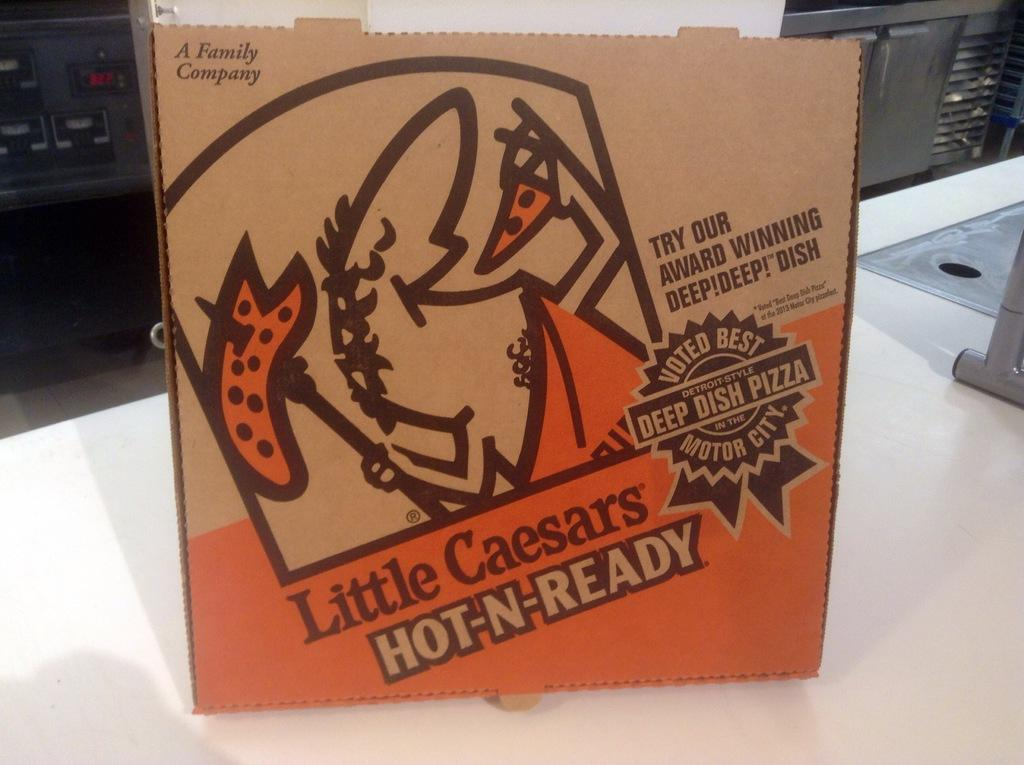<image>
Present a compact description of the photo's key features. A box for food made at Little Caesars. 